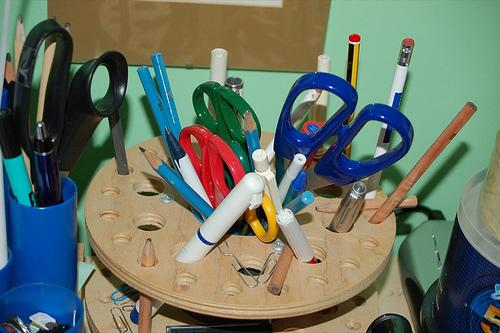What class are these supplies needed for? art 